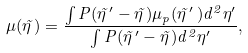Convert formula to latex. <formula><loc_0><loc_0><loc_500><loc_500>\mu ( \vec { \eta } \, ) = \frac { \int P ( \vec { \eta } \, ^ { \prime } - \vec { \eta } \, ) \mu _ { p } ( \vec { \eta } \, ^ { \prime } \, ) d ^ { 2 } \eta ^ { \prime } } { \int P ( \vec { \eta } \, ^ { \prime } - \vec { \eta } \, ) d ^ { 2 } \eta ^ { \prime } } ,</formula> 